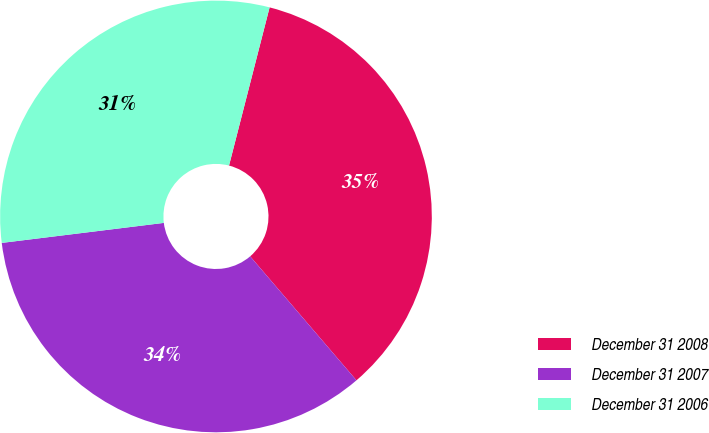<chart> <loc_0><loc_0><loc_500><loc_500><pie_chart><fcel>December 31 2008<fcel>December 31 2007<fcel>December 31 2006<nl><fcel>34.72%<fcel>34.32%<fcel>30.95%<nl></chart> 